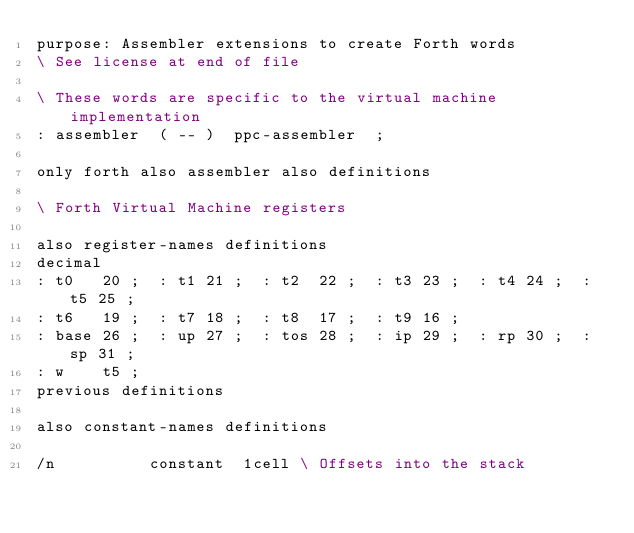Convert code to text. <code><loc_0><loc_0><loc_500><loc_500><_Forth_>purpose: Assembler extensions to create Forth words
\ See license at end of file

\ These words are specific to the virtual machine implementation
: assembler  ( -- )  ppc-assembler  ;

only forth also assembler also definitions

\ Forth Virtual Machine registers

also register-names definitions
decimal
: t0   20 ;  : t1 21 ;  : t2  22 ;  : t3 23 ;  : t4 24 ;  : t5 25 ;
: t6   19 ;  : t7 18 ;  : t8  17 ;  : t9 16 ;
: base 26 ;  : up 27 ;  : tos 28 ;  : ip 29 ;  : rp 30 ;  : sp 31 ;
: w    t5 ;
previous definitions

also constant-names definitions

/n          constant  1cell	\ Offsets into the stack</code> 